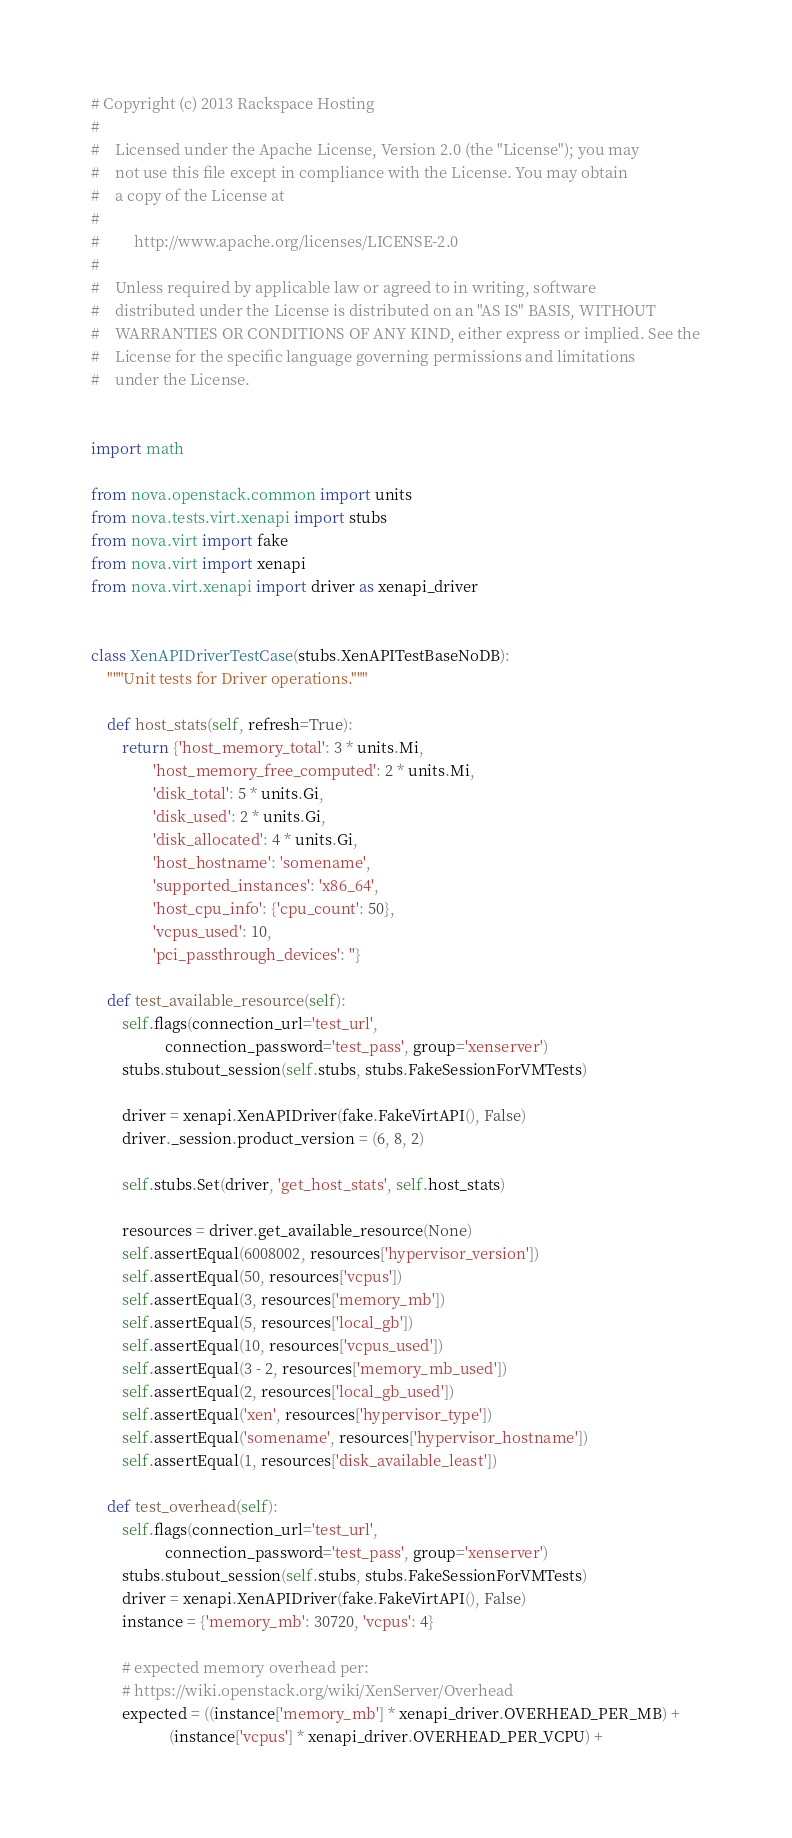Convert code to text. <code><loc_0><loc_0><loc_500><loc_500><_Python_># Copyright (c) 2013 Rackspace Hosting
#
#    Licensed under the Apache License, Version 2.0 (the "License"); you may
#    not use this file except in compliance with the License. You may obtain
#    a copy of the License at
#
#         http://www.apache.org/licenses/LICENSE-2.0
#
#    Unless required by applicable law or agreed to in writing, software
#    distributed under the License is distributed on an "AS IS" BASIS, WITHOUT
#    WARRANTIES OR CONDITIONS OF ANY KIND, either express or implied. See the
#    License for the specific language governing permissions and limitations
#    under the License.


import math

from nova.openstack.common import units
from nova.tests.virt.xenapi import stubs
from nova.virt import fake
from nova.virt import xenapi
from nova.virt.xenapi import driver as xenapi_driver


class XenAPIDriverTestCase(stubs.XenAPITestBaseNoDB):
    """Unit tests for Driver operations."""

    def host_stats(self, refresh=True):
        return {'host_memory_total': 3 * units.Mi,
                'host_memory_free_computed': 2 * units.Mi,
                'disk_total': 5 * units.Gi,
                'disk_used': 2 * units.Gi,
                'disk_allocated': 4 * units.Gi,
                'host_hostname': 'somename',
                'supported_instances': 'x86_64',
                'host_cpu_info': {'cpu_count': 50},
                'vcpus_used': 10,
                'pci_passthrough_devices': ''}

    def test_available_resource(self):
        self.flags(connection_url='test_url',
                   connection_password='test_pass', group='xenserver')
        stubs.stubout_session(self.stubs, stubs.FakeSessionForVMTests)

        driver = xenapi.XenAPIDriver(fake.FakeVirtAPI(), False)
        driver._session.product_version = (6, 8, 2)

        self.stubs.Set(driver, 'get_host_stats', self.host_stats)

        resources = driver.get_available_resource(None)
        self.assertEqual(6008002, resources['hypervisor_version'])
        self.assertEqual(50, resources['vcpus'])
        self.assertEqual(3, resources['memory_mb'])
        self.assertEqual(5, resources['local_gb'])
        self.assertEqual(10, resources['vcpus_used'])
        self.assertEqual(3 - 2, resources['memory_mb_used'])
        self.assertEqual(2, resources['local_gb_used'])
        self.assertEqual('xen', resources['hypervisor_type'])
        self.assertEqual('somename', resources['hypervisor_hostname'])
        self.assertEqual(1, resources['disk_available_least'])

    def test_overhead(self):
        self.flags(connection_url='test_url',
                   connection_password='test_pass', group='xenserver')
        stubs.stubout_session(self.stubs, stubs.FakeSessionForVMTests)
        driver = xenapi.XenAPIDriver(fake.FakeVirtAPI(), False)
        instance = {'memory_mb': 30720, 'vcpus': 4}

        # expected memory overhead per:
        # https://wiki.openstack.org/wiki/XenServer/Overhead
        expected = ((instance['memory_mb'] * xenapi_driver.OVERHEAD_PER_MB) +
                    (instance['vcpus'] * xenapi_driver.OVERHEAD_PER_VCPU) +</code> 